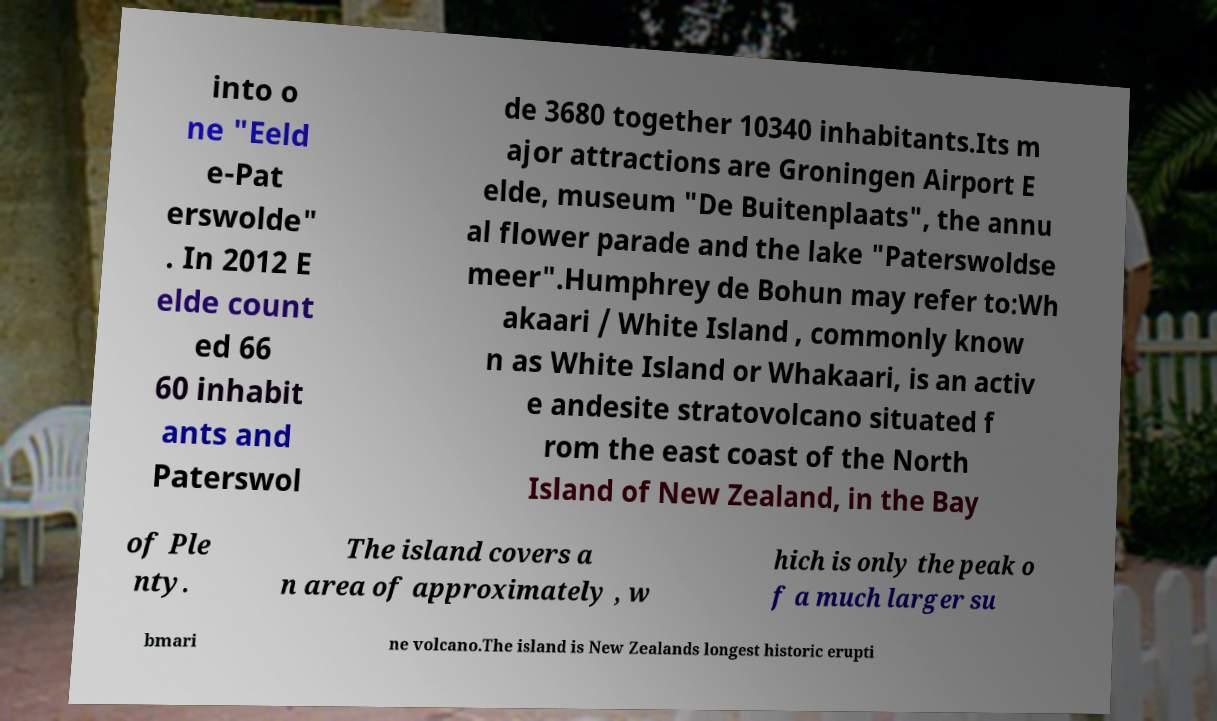Please read and relay the text visible in this image. What does it say? into o ne "Eeld e-Pat erswolde" . In 2012 E elde count ed 66 60 inhabit ants and Paterswol de 3680 together 10340 inhabitants.Its m ajor attractions are Groningen Airport E elde, museum "De Buitenplaats", the annu al flower parade and the lake "Paterswoldse meer".Humphrey de Bohun may refer to:Wh akaari / White Island , commonly know n as White Island or Whakaari, is an activ e andesite stratovolcano situated f rom the east coast of the North Island of New Zealand, in the Bay of Ple nty. The island covers a n area of approximately , w hich is only the peak o f a much larger su bmari ne volcano.The island is New Zealands longest historic erupti 